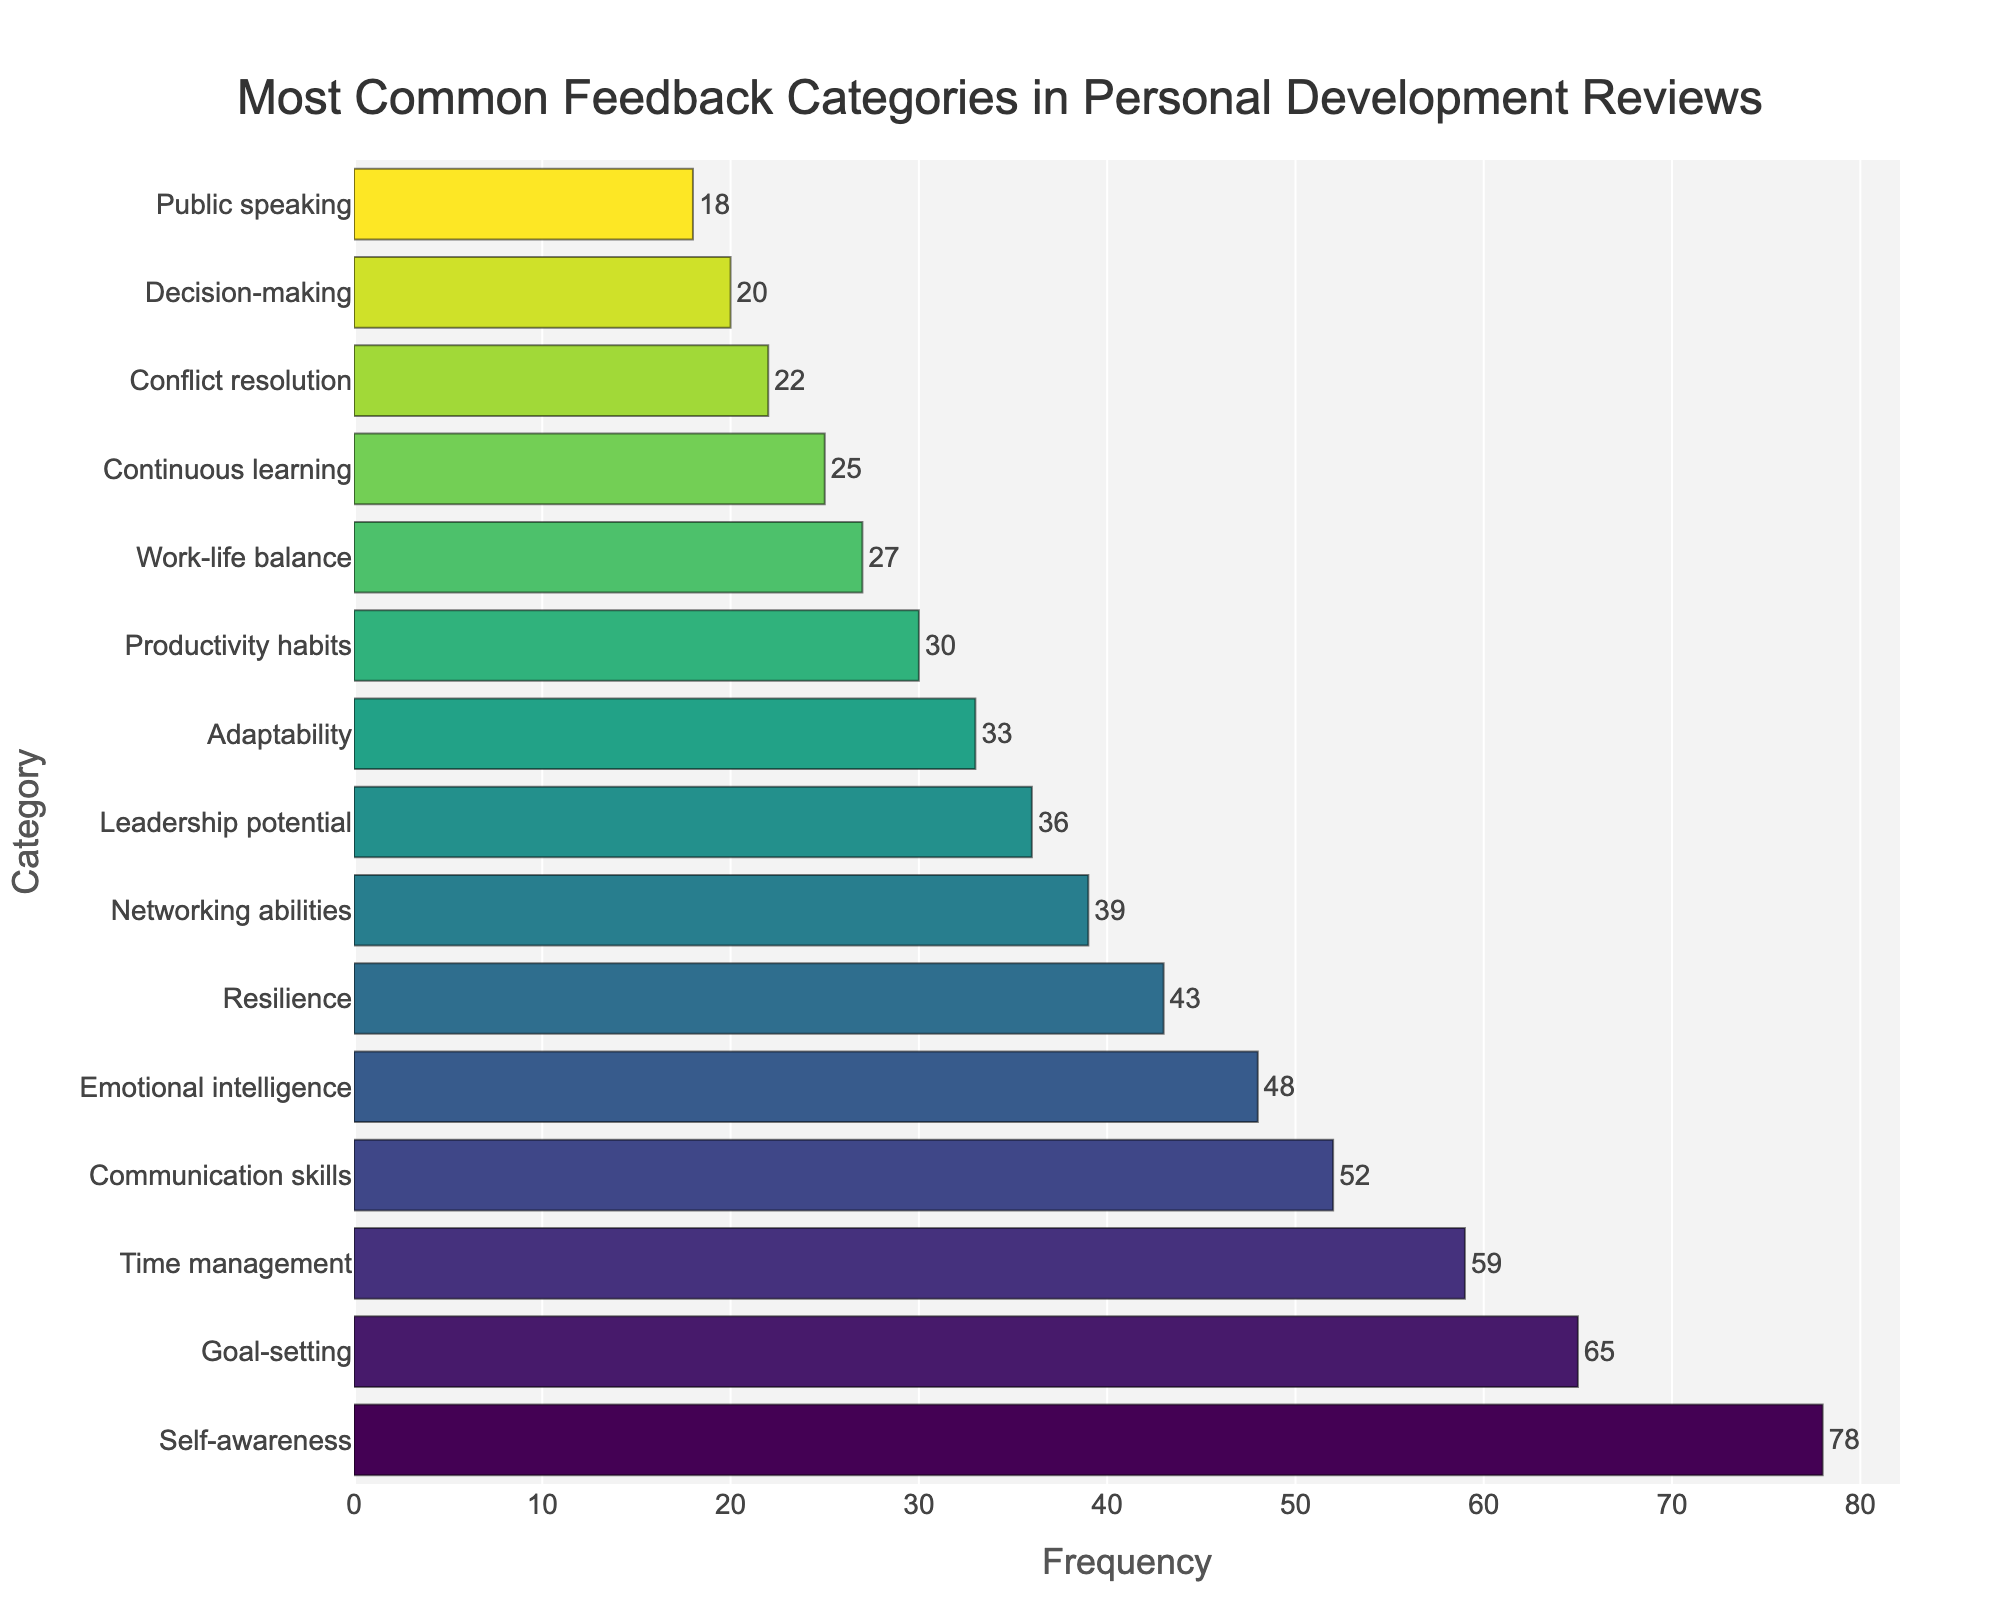What is the most common feedback category in personal development reviews? The most common feedback category is the one with the highest frequency on the bar chart. The longest bar represents the "Self-awareness" category, which has the highest frequency.
Answer: Self-awareness Which feedback category has the lowest frequency? The category with the shortest bar has the lowest frequency. This is the "Public speaking" category, which is shown with the least length.
Answer: Public speaking How many categories have a frequency above 50? Look at the bars and count the number of bars with a frequency greater than 50. The categories are "Self-awareness," "Goal-setting," "Time management," and "Communication skills." There are 4 of them.
Answer: 4 What is the combined frequency of "Emotional intelligence" and "Resilience"? To find this, look at the frequencies for both categories and sum them. "Emotional intelligence" has a frequency of 48, and "Resilience" has 43. Therefore, 48 + 43 = 91.
Answer: 91 Which has a higher frequency: "Decision-making" or "Conflict resolution"? Compare the lengths of the bars for "Decision-making" and "Conflict resolution." "Conflict resolution" has a frequency of 22, while "Decision-making" has a frequency of 20. Therefore, "Conflict resolution" is higher.
Answer: Conflict resolution What percentage of the total frequency does "Goal-setting" represent? First, calculate the total frequency sum of all categories, which is 565. The frequency for "Goal-setting" is 65. Calculate the percentage by (65 / 565) * 100.
Answer: 11.50% Which category has a higher frequency, “Networking abilities” or “Adaptability,” and by how much? Look at the bars for both "Networking abilities" (39) and "Adaptability" (33). Subtract the smaller frequency from the larger one: 39 - 33 = 6.
Answer: Networking abilities by 6 What's the average frequency of the top three categories? Identify the top three categories ("Self-awareness": 78, "Goal-setting": 65, "Time management": 59), sum them (78 + 65 + 59 = 202), and divide by 3 (202 / 3).
Answer: 67.33 